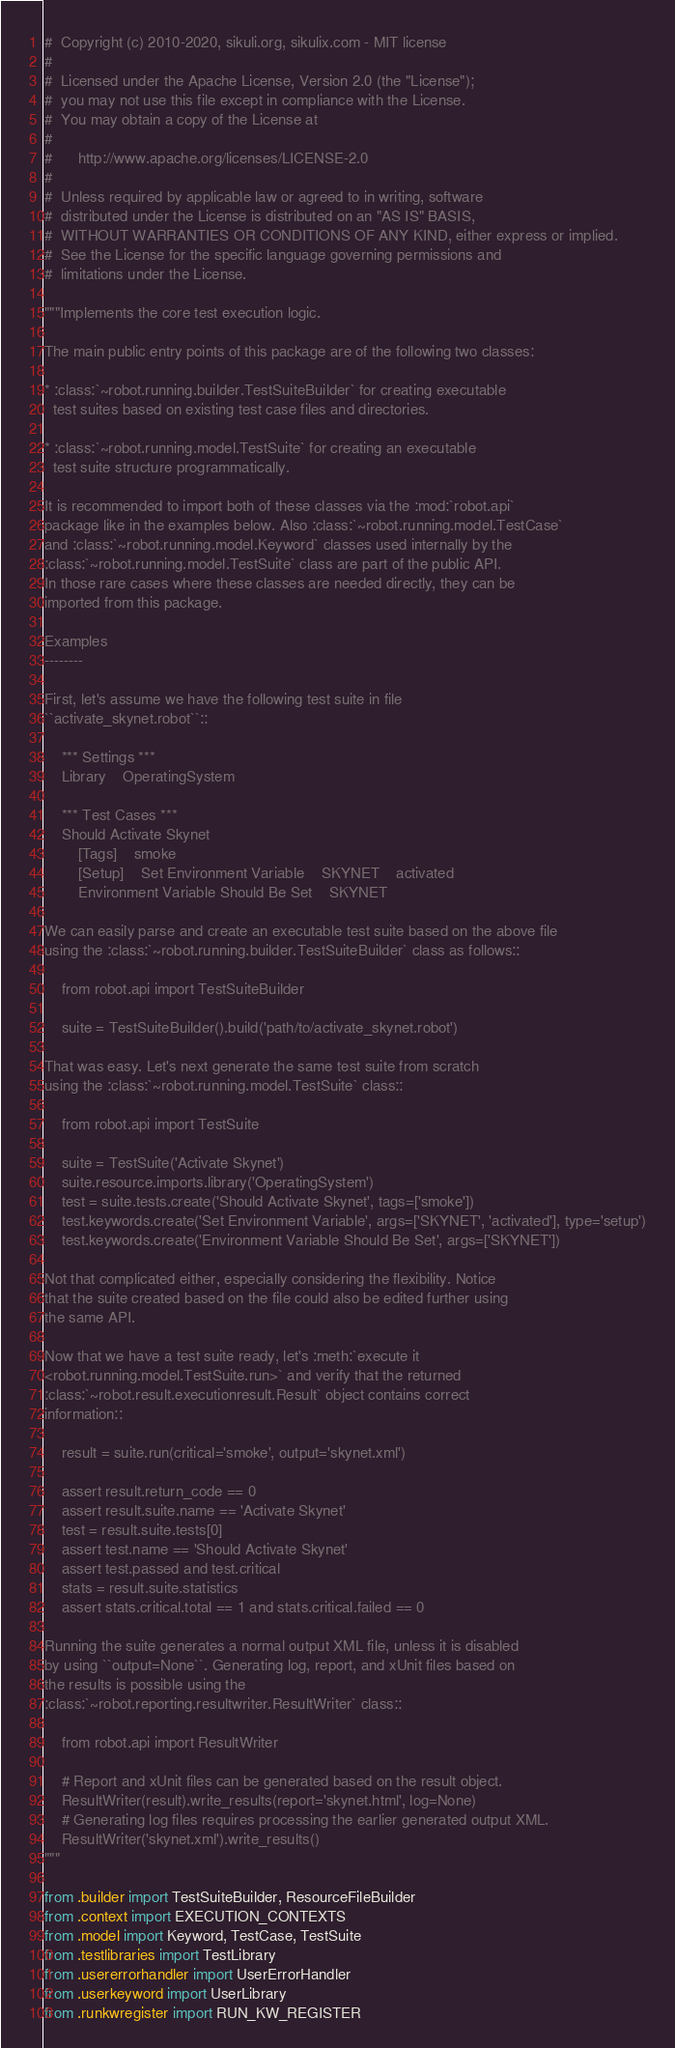Convert code to text. <code><loc_0><loc_0><loc_500><loc_500><_Python_>#  Copyright (c) 2010-2020, sikuli.org, sikulix.com - MIT license
#
#  Licensed under the Apache License, Version 2.0 (the "License");
#  you may not use this file except in compliance with the License.
#  You may obtain a copy of the License at
#
#      http://www.apache.org/licenses/LICENSE-2.0
#
#  Unless required by applicable law or agreed to in writing, software
#  distributed under the License is distributed on an "AS IS" BASIS,
#  WITHOUT WARRANTIES OR CONDITIONS OF ANY KIND, either express or implied.
#  See the License for the specific language governing permissions and
#  limitations under the License.

"""Implements the core test execution logic.

The main public entry points of this package are of the following two classes:

* :class:`~robot.running.builder.TestSuiteBuilder` for creating executable
  test suites based on existing test case files and directories.

* :class:`~robot.running.model.TestSuite` for creating an executable
  test suite structure programmatically.

It is recommended to import both of these classes via the :mod:`robot.api`
package like in the examples below. Also :class:`~robot.running.model.TestCase`
and :class:`~robot.running.model.Keyword` classes used internally by the
:class:`~robot.running.model.TestSuite` class are part of the public API.
In those rare cases where these classes are needed directly, they can be
imported from this package.

Examples
--------

First, let's assume we have the following test suite in file
``activate_skynet.robot``::

    *** Settings ***
    Library    OperatingSystem

    *** Test Cases ***
    Should Activate Skynet
        [Tags]    smoke
        [Setup]    Set Environment Variable    SKYNET    activated
        Environment Variable Should Be Set    SKYNET

We can easily parse and create an executable test suite based on the above file
using the :class:`~robot.running.builder.TestSuiteBuilder` class as follows::

    from robot.api import TestSuiteBuilder

    suite = TestSuiteBuilder().build('path/to/activate_skynet.robot')

That was easy. Let's next generate the same test suite from scratch
using the :class:`~robot.running.model.TestSuite` class::

    from robot.api import TestSuite

    suite = TestSuite('Activate Skynet')
    suite.resource.imports.library('OperatingSystem')
    test = suite.tests.create('Should Activate Skynet', tags=['smoke'])
    test.keywords.create('Set Environment Variable', args=['SKYNET', 'activated'], type='setup')
    test.keywords.create('Environment Variable Should Be Set', args=['SKYNET'])

Not that complicated either, especially considering the flexibility. Notice
that the suite created based on the file could also be edited further using
the same API.

Now that we have a test suite ready, let's :meth:`execute it
<robot.running.model.TestSuite.run>` and verify that the returned
:class:`~robot.result.executionresult.Result` object contains correct
information::

    result = suite.run(critical='smoke', output='skynet.xml')

    assert result.return_code == 0
    assert result.suite.name == 'Activate Skynet'
    test = result.suite.tests[0]
    assert test.name == 'Should Activate Skynet'
    assert test.passed and test.critical
    stats = result.suite.statistics
    assert stats.critical.total == 1 and stats.critical.failed == 0

Running the suite generates a normal output XML file, unless it is disabled
by using ``output=None``. Generating log, report, and xUnit files based on
the results is possible using the
:class:`~robot.reporting.resultwriter.ResultWriter` class::

    from robot.api import ResultWriter

    # Report and xUnit files can be generated based on the result object.
    ResultWriter(result).write_results(report='skynet.html', log=None)
    # Generating log files requires processing the earlier generated output XML.
    ResultWriter('skynet.xml').write_results()
"""

from .builder import TestSuiteBuilder, ResourceFileBuilder
from .context import EXECUTION_CONTEXTS
from .model import Keyword, TestCase, TestSuite
from .testlibraries import TestLibrary
from .usererrorhandler import UserErrorHandler
from .userkeyword import UserLibrary
from .runkwregister import RUN_KW_REGISTER
</code> 